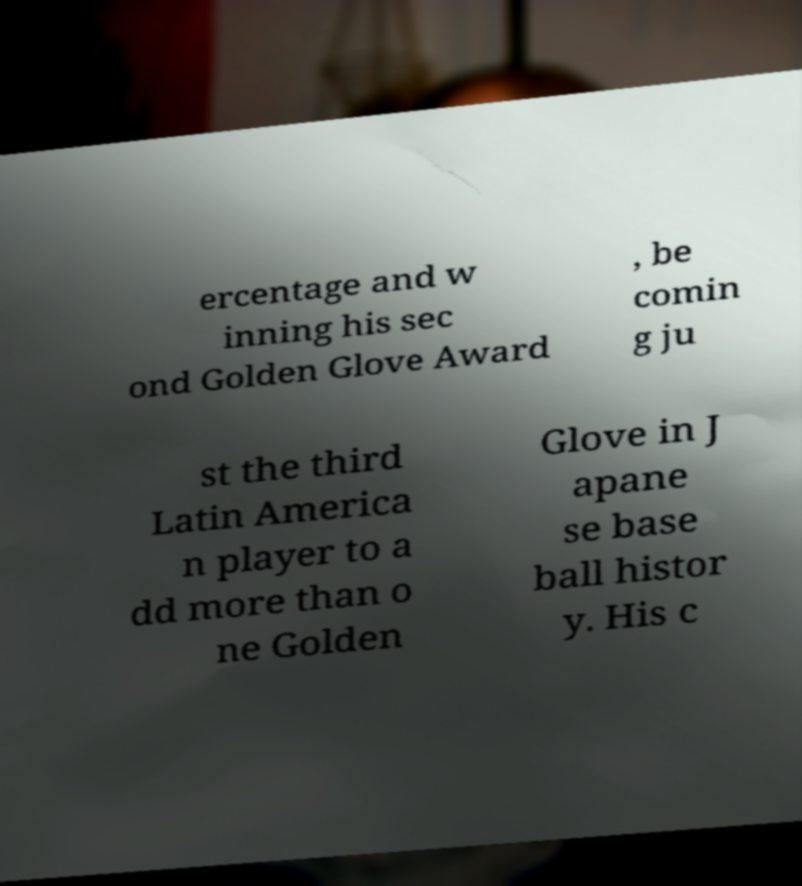Could you assist in decoding the text presented in this image and type it out clearly? ercentage and w inning his sec ond Golden Glove Award , be comin g ju st the third Latin America n player to a dd more than o ne Golden Glove in J apane se base ball histor y. His c 